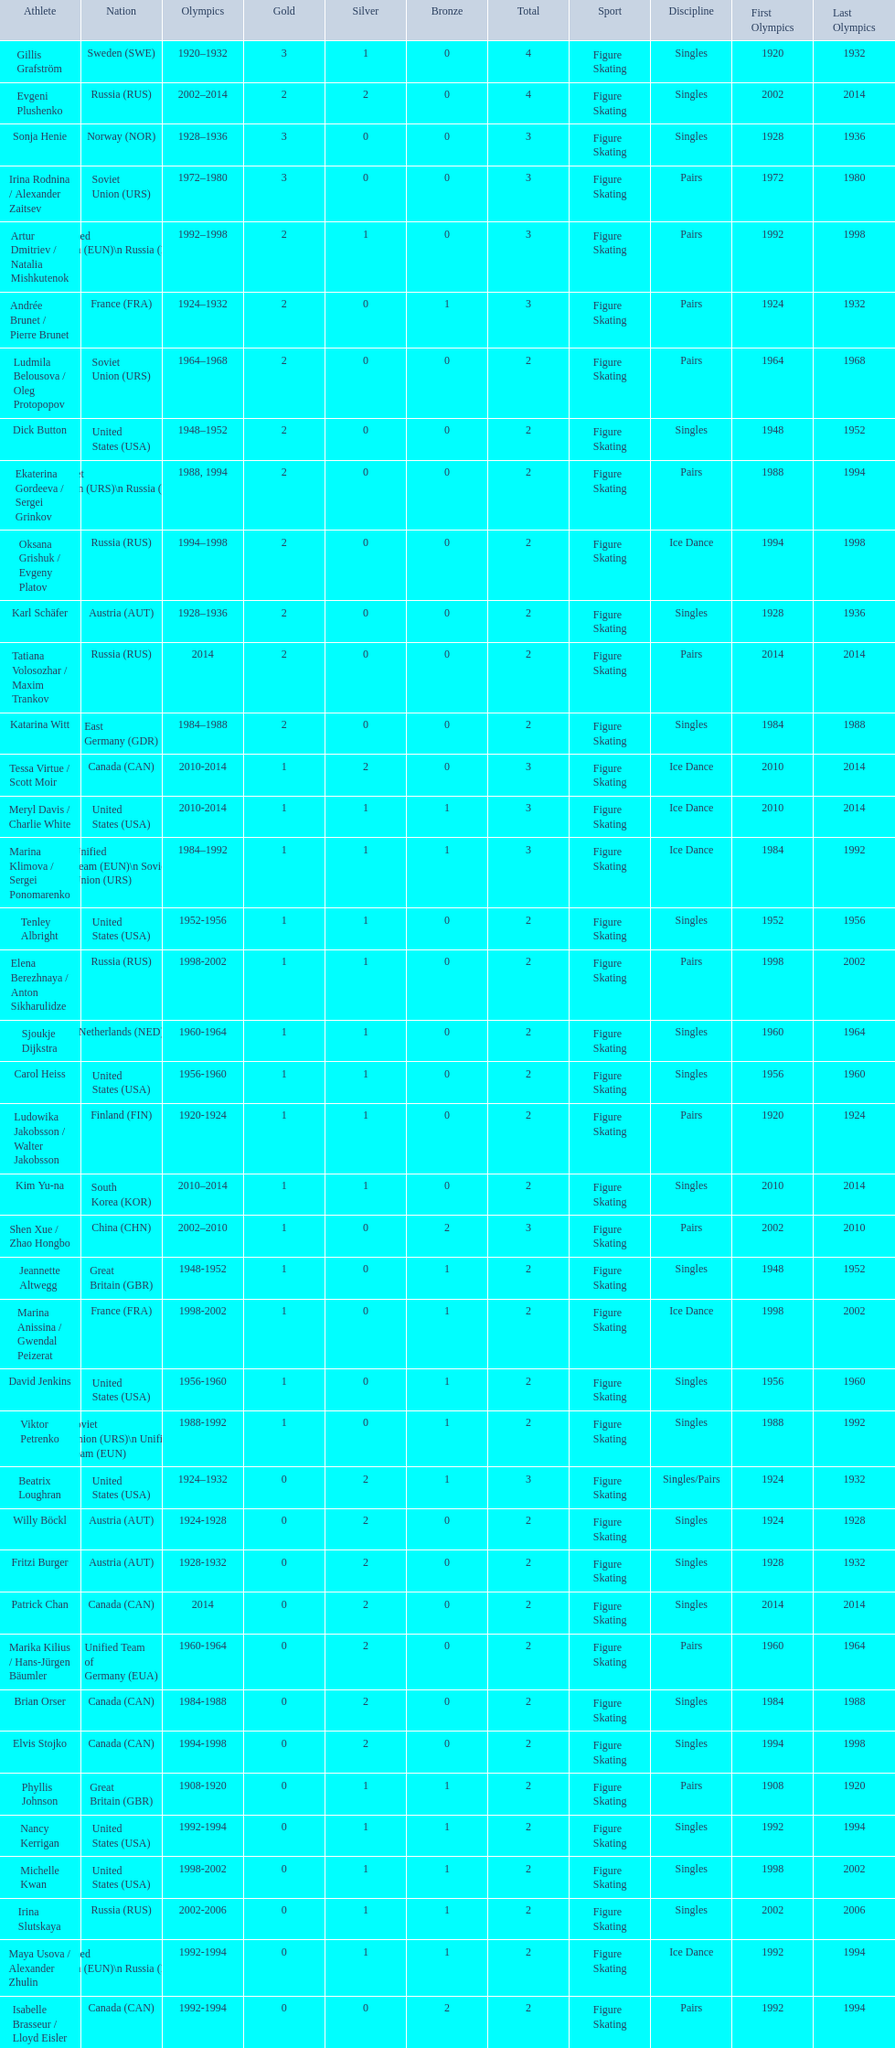What is the maximum number of gold medals ever won by one athlete? 3. 